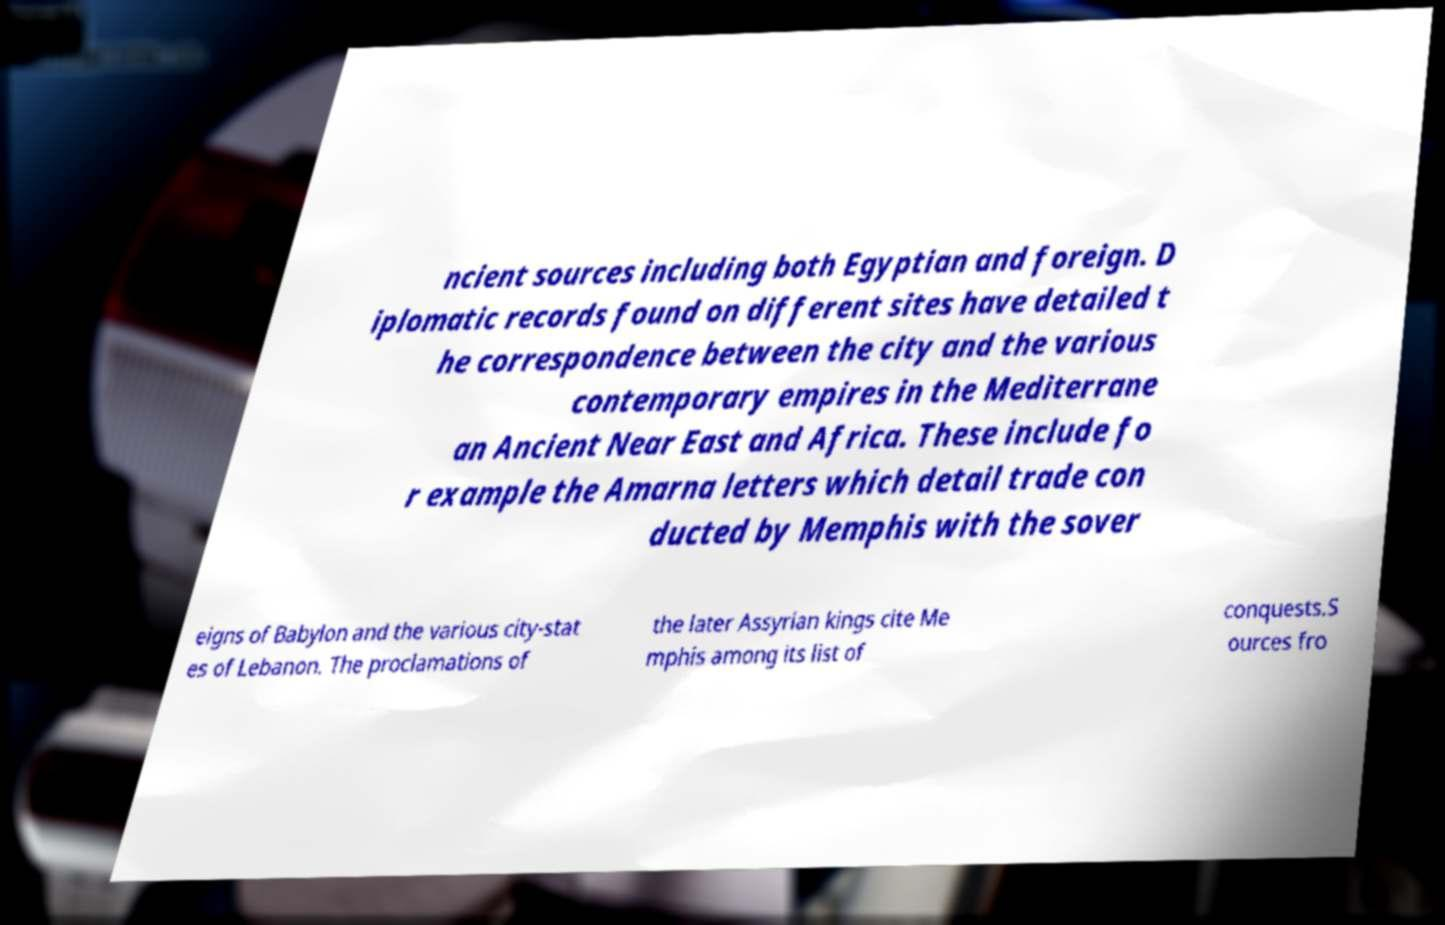I need the written content from this picture converted into text. Can you do that? ncient sources including both Egyptian and foreign. D iplomatic records found on different sites have detailed t he correspondence between the city and the various contemporary empires in the Mediterrane an Ancient Near East and Africa. These include fo r example the Amarna letters which detail trade con ducted by Memphis with the sover eigns of Babylon and the various city-stat es of Lebanon. The proclamations of the later Assyrian kings cite Me mphis among its list of conquests.S ources fro 